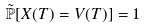<formula> <loc_0><loc_0><loc_500><loc_500>\tilde { \mathbb { P } } [ X ( T ) = V ( T ) ] = 1</formula> 